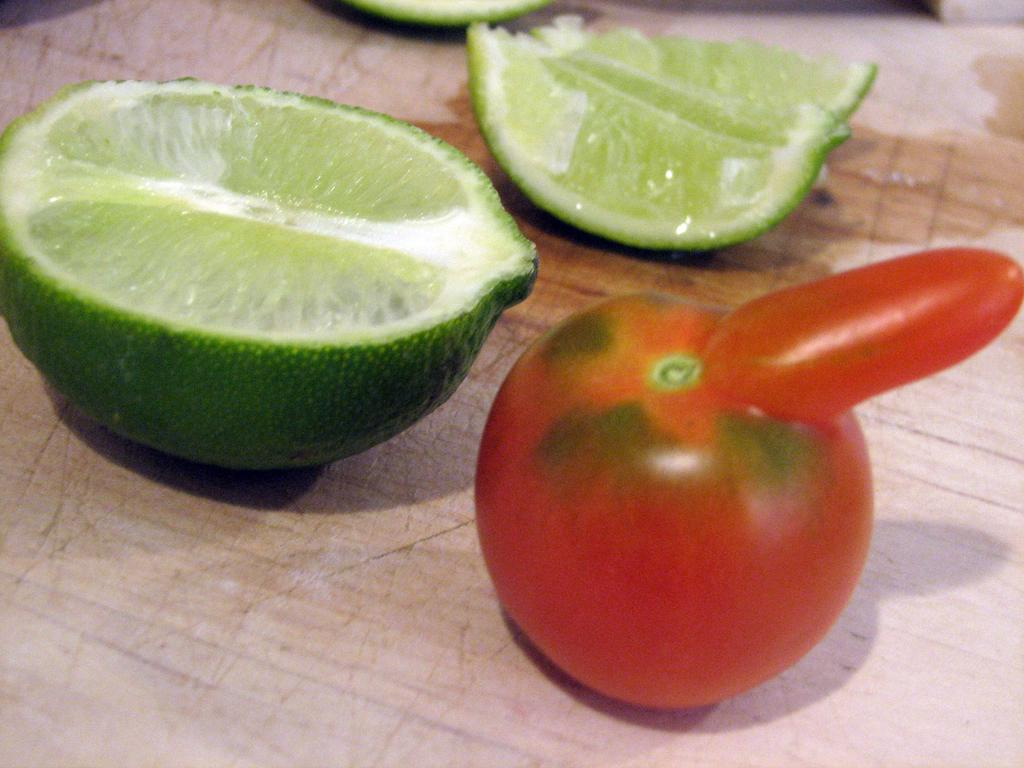What type of fruit can be seen in the image? There are lemon slices and a tomato in the image. What is the surface on which the lemon slices and tomato are placed? The lemon slices and tomato are on a wooden platform. What type of rifle is visible on the wooden platform in the image? There is no rifle present in the image; it only features lemon slices and a tomato on a wooden platform. 